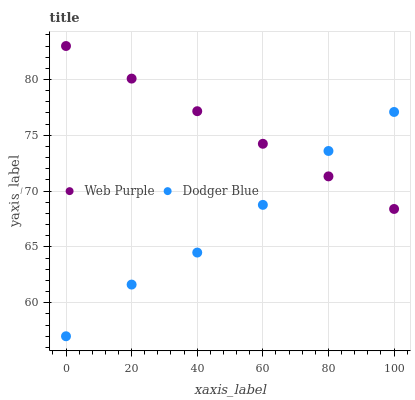Does Dodger Blue have the minimum area under the curve?
Answer yes or no. Yes. Does Web Purple have the maximum area under the curve?
Answer yes or no. Yes. Does Dodger Blue have the maximum area under the curve?
Answer yes or no. No. Is Web Purple the smoothest?
Answer yes or no. Yes. Is Dodger Blue the roughest?
Answer yes or no. Yes. Is Dodger Blue the smoothest?
Answer yes or no. No. Does Dodger Blue have the lowest value?
Answer yes or no. Yes. Does Web Purple have the highest value?
Answer yes or no. Yes. Does Dodger Blue have the highest value?
Answer yes or no. No. Does Web Purple intersect Dodger Blue?
Answer yes or no. Yes. Is Web Purple less than Dodger Blue?
Answer yes or no. No. Is Web Purple greater than Dodger Blue?
Answer yes or no. No. 